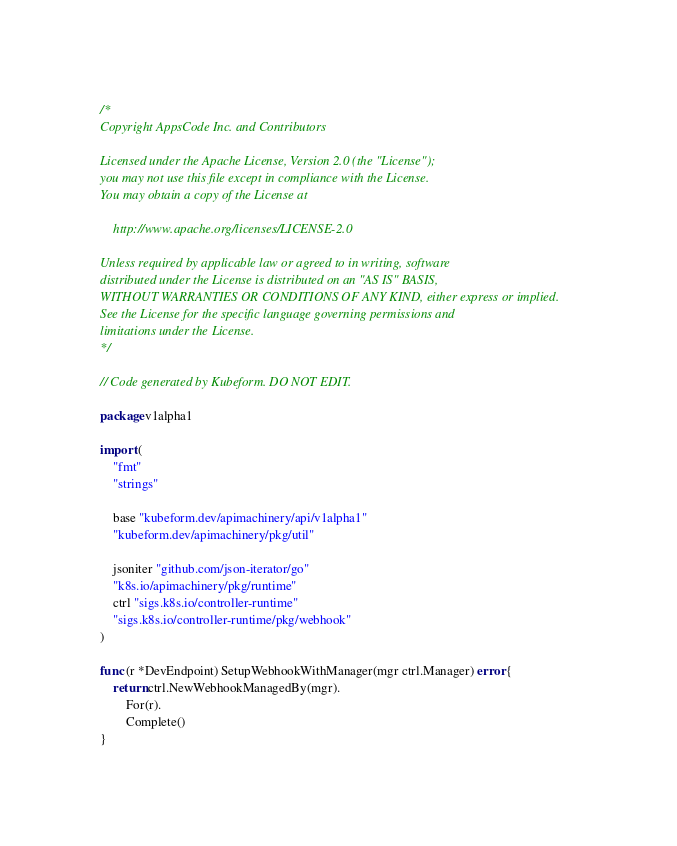Convert code to text. <code><loc_0><loc_0><loc_500><loc_500><_Go_>/*
Copyright AppsCode Inc. and Contributors

Licensed under the Apache License, Version 2.0 (the "License");
you may not use this file except in compliance with the License.
You may obtain a copy of the License at

    http://www.apache.org/licenses/LICENSE-2.0

Unless required by applicable law or agreed to in writing, software
distributed under the License is distributed on an "AS IS" BASIS,
WITHOUT WARRANTIES OR CONDITIONS OF ANY KIND, either express or implied.
See the License for the specific language governing permissions and
limitations under the License.
*/

// Code generated by Kubeform. DO NOT EDIT.

package v1alpha1

import (
	"fmt"
	"strings"

	base "kubeform.dev/apimachinery/api/v1alpha1"
	"kubeform.dev/apimachinery/pkg/util"

	jsoniter "github.com/json-iterator/go"
	"k8s.io/apimachinery/pkg/runtime"
	ctrl "sigs.k8s.io/controller-runtime"
	"sigs.k8s.io/controller-runtime/pkg/webhook"
)

func (r *DevEndpoint) SetupWebhookWithManager(mgr ctrl.Manager) error {
	return ctrl.NewWebhookManagedBy(mgr).
		For(r).
		Complete()
}
</code> 